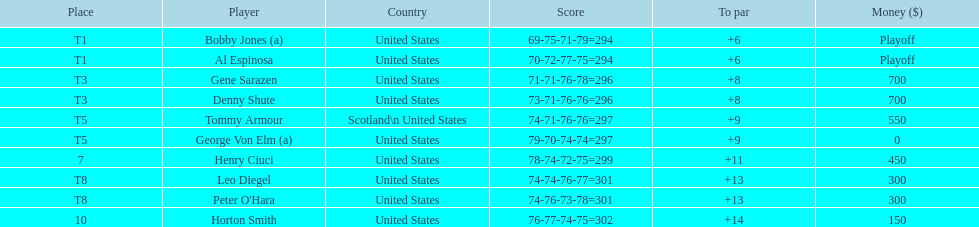Did tommy armour place above or below denny shute? Below. Write the full table. {'header': ['Place', 'Player', 'Country', 'Score', 'To par', 'Money ($)'], 'rows': [['T1', 'Bobby Jones (a)', 'United States', '69-75-71-79=294', '+6', 'Playoff'], ['T1', 'Al Espinosa', 'United States', '70-72-77-75=294', '+6', 'Playoff'], ['T3', 'Gene Sarazen', 'United States', '71-71-76-78=296', '+8', '700'], ['T3', 'Denny Shute', 'United States', '73-71-76-76=296', '+8', '700'], ['T5', 'Tommy Armour', 'Scotland\\n\xa0United States', '74-71-76-76=297', '+9', '550'], ['T5', 'George Von Elm (a)', 'United States', '79-70-74-74=297', '+9', '0'], ['7', 'Henry Ciuci', 'United States', '78-74-72-75=299', '+11', '450'], ['T8', 'Leo Diegel', 'United States', '74-74-76-77=301', '+13', '300'], ['T8', "Peter O'Hara", 'United States', '74-76-73-78=301', '+13', '300'], ['10', 'Horton Smith', 'United States', '76-77-74-75=302', '+14', '150']]} 